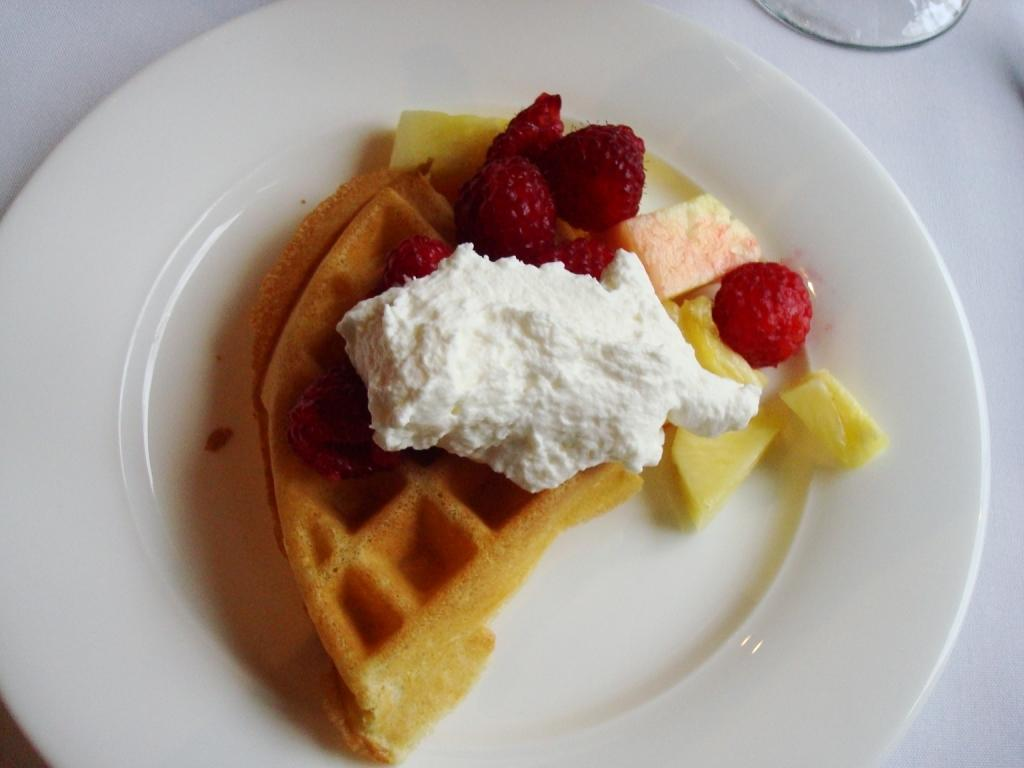What is on the plate that is visible in the image? There is food on a plate in the image. What else can be seen in the image besides the plate of food? There is a glass on a white surface visible in the image. What type of sweater is the baby wearing in the image? There is no baby or sweater present in the image. What type of insurance policy is being discussed in the image? There is no discussion of insurance policies in the image. 